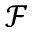<formula> <loc_0><loc_0><loc_500><loc_500>\mathcal { F }</formula> 